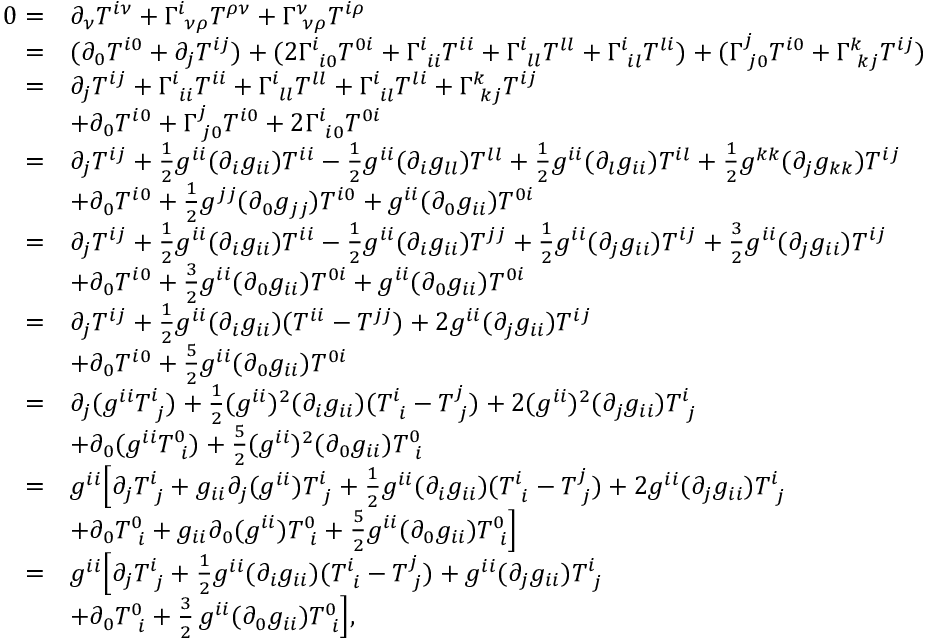<formula> <loc_0><loc_0><loc_500><loc_500>\begin{array} { r l } { 0 = } & { \partial _ { \nu } T ^ { i \nu } + \Gamma _ { \, \nu \rho } ^ { i } T ^ { \rho \nu } + \Gamma _ { \, \nu \rho } ^ { \nu } T ^ { i \rho } } \\ { = } & { ( \partial _ { 0 } T ^ { i 0 } + \partial _ { j } T ^ { i j } ) + ( 2 \Gamma _ { \, i 0 } ^ { i } T ^ { 0 i } + \Gamma _ { \, i i } ^ { i } T ^ { i i } + \Gamma _ { \, l l } ^ { i } T ^ { l l } + \Gamma _ { \, i l } ^ { i } T ^ { l i } ) + ( \Gamma _ { \, j 0 } ^ { j } T ^ { i 0 } + \Gamma _ { \, k j } ^ { k } T ^ { i j } ) } \\ { = } & { \partial _ { j } T ^ { i j } + \Gamma _ { \, i i } ^ { i } T ^ { i i } + \Gamma _ { \, l l } ^ { i } T ^ { l l } + \Gamma _ { \, i l } ^ { i } T ^ { l i } + \Gamma _ { \, k j } ^ { k } T ^ { i j } } \\ & { + \partial _ { 0 } T ^ { i 0 } + \Gamma _ { \, j 0 } ^ { j } T ^ { i 0 } + 2 \Gamma _ { \, i 0 } ^ { i } T ^ { 0 i } } \\ { = } & { \partial _ { j } T ^ { i j } + \frac { 1 } { 2 } g ^ { i i } ( \partial _ { i } g _ { i i } ) T ^ { i i } - \frac { 1 } { 2 } g ^ { i i } ( \partial _ { i } g _ { l l } ) T ^ { l l } + \frac { 1 } { 2 } g ^ { i i } ( \partial _ { l } g _ { i i } ) T ^ { i l } + \frac { 1 } { 2 } g ^ { k k } ( \partial _ { j } g _ { k k } ) T ^ { i j } } \\ & { + \partial _ { 0 } T ^ { i 0 } + \frac { 1 } { 2 } g ^ { j j } ( \partial _ { 0 } g _ { j j } ) T ^ { i 0 } + g ^ { i i } ( \partial _ { 0 } g _ { i i } ) T ^ { 0 i } } \\ { = } & { \partial _ { j } T ^ { i j } + \frac { 1 } { 2 } g ^ { i i } ( \partial _ { i } g _ { i i } ) T ^ { i i } - \frac { 1 } { 2 } g ^ { i i } ( \partial _ { i } g _ { i i } ) T ^ { j j } + \frac { 1 } { 2 } g ^ { i i } ( \partial _ { j } g _ { i i } ) T ^ { i j } + \frac { 3 } { 2 } g ^ { i i } ( \partial _ { j } g _ { i i } ) T ^ { i j } } \\ & { + \partial _ { 0 } T ^ { i 0 } + \frac { 3 } { 2 } g ^ { i i } ( \partial _ { 0 } g _ { i i } ) T ^ { 0 i } + g ^ { i i } ( \partial _ { 0 } g _ { i i } ) T ^ { 0 i } } \\ { = } & { \partial _ { j } T ^ { i j } + \frac { 1 } { 2 } g ^ { i i } ( \partial _ { i } g _ { i i } ) ( T ^ { i i } - T ^ { j j } ) + 2 g ^ { i i } ( \partial _ { j } g _ { i i } ) T ^ { i j } } \\ & { + \partial _ { 0 } T ^ { i 0 } + \frac { 5 } { 2 } g ^ { i i } ( \partial _ { 0 } g _ { i i } ) T ^ { 0 i } } \\ { = } & { \partial _ { j } ( g ^ { i i } T _ { \, j } ^ { i } ) + \frac { 1 } { 2 } ( g ^ { i i } ) ^ { 2 } ( \partial _ { i } g _ { i i } ) ( T _ { \, i } ^ { i } - T _ { \, j } ^ { j } ) + 2 ( g ^ { i i } ) ^ { 2 } ( \partial _ { j } g _ { i i } ) T _ { \, j } ^ { i } } \\ & { + \partial _ { 0 } ( g ^ { i i } T _ { \, i } ^ { 0 } ) + \frac { 5 } { 2 } ( g ^ { i i } ) ^ { 2 } ( \partial _ { 0 } g _ { i i } ) T _ { \, i } ^ { 0 } } \\ { = } & { g ^ { i i } \left [ \partial _ { j } T _ { \, j } ^ { i } + g _ { i i } \partial _ { j } ( g ^ { i i } ) T _ { \, j } ^ { i } + \frac { 1 } { 2 } g ^ { i i } ( \partial _ { i } g _ { i i } ) ( T _ { \, i } ^ { i } - T _ { \, j } ^ { j } ) + 2 g ^ { i i } ( \partial _ { j } g _ { i i } ) T _ { \, j } ^ { i } } \\ & { + \partial _ { 0 } T _ { \, i } ^ { 0 } + g _ { i i } \partial _ { 0 } ( g ^ { i i } ) T _ { \, i } ^ { 0 } + \frac { 5 } { 2 } g ^ { i i } ( \partial _ { 0 } g _ { i i } ) T _ { \, i } ^ { 0 } \right ] } \\ { = } & { g ^ { i i } \left [ \partial _ { j } T _ { \, j } ^ { i } + \frac { 1 } { 2 } g ^ { i i } ( \partial _ { i } g _ { i i } ) ( T _ { \, i } ^ { i } - T _ { \, j } ^ { j } ) + g ^ { i i } ( \partial _ { j } g _ { i i } ) T _ { \, j } ^ { i } } \\ & { + \partial _ { 0 } T _ { \, i } ^ { 0 } + \frac { 3 } { 2 } \, g ^ { i i } ( \partial _ { 0 } g _ { i i } ) T _ { \, i } ^ { 0 } \right ] , } \end{array}</formula> 